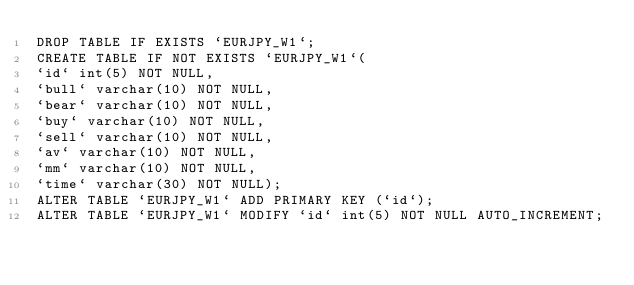<code> <loc_0><loc_0><loc_500><loc_500><_SQL_>DROP TABLE IF EXISTS `EURJPY_W1`;
CREATE TABLE IF NOT EXISTS `EURJPY_W1`(
`id` int(5) NOT NULL,
`bull` varchar(10) NOT NULL,
`bear` varchar(10) NOT NULL,
`buy` varchar(10) NOT NULL,
`sell` varchar(10) NOT NULL,
`av` varchar(10) NOT NULL,
`mm` varchar(10) NOT NULL,
`time` varchar(30) NOT NULL);
ALTER TABLE `EURJPY_W1` ADD PRIMARY KEY (`id`);
ALTER TABLE `EURJPY_W1` MODIFY `id` int(5) NOT NULL AUTO_INCREMENT;</code> 